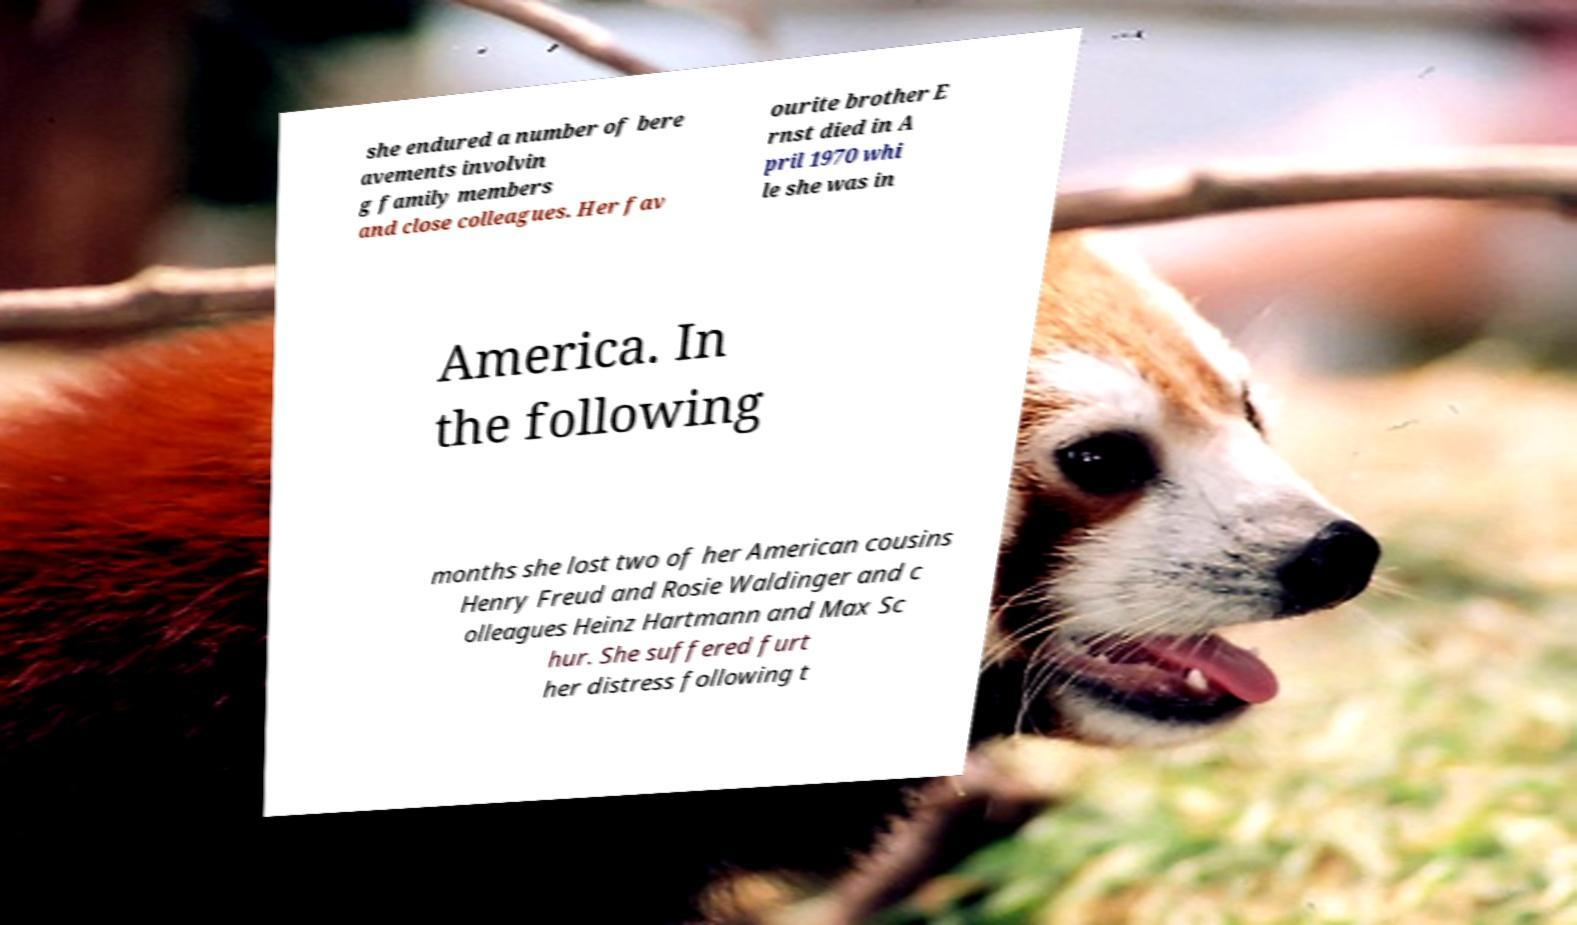Please read and relay the text visible in this image. What does it say? she endured a number of bere avements involvin g family members and close colleagues. Her fav ourite brother E rnst died in A pril 1970 whi le she was in America. In the following months she lost two of her American cousins Henry Freud and Rosie Waldinger and c olleagues Heinz Hartmann and Max Sc hur. She suffered furt her distress following t 